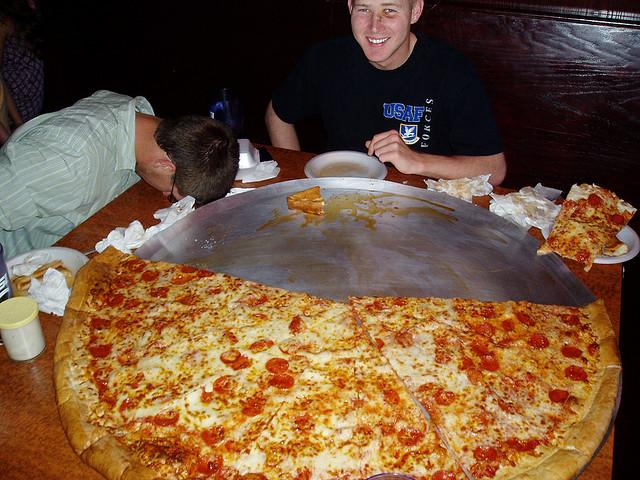Will the guys finish the pizza?
Quick response, please. No. Is the pizza small?
Answer briefly. No. What are the letters on the black shirt that the smiling guy is wearing?
Be succinct. Usaf. 